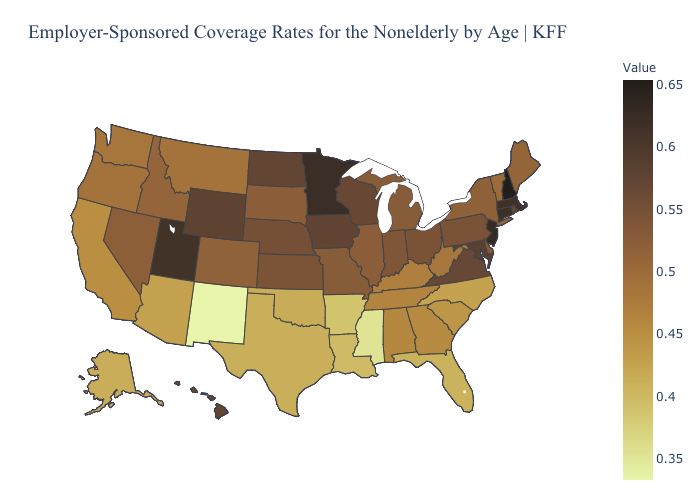Among the states that border Arkansas , which have the lowest value?
Concise answer only. Mississippi. Which states have the highest value in the USA?
Keep it brief. New Hampshire. Does Mississippi have the lowest value in the South?
Answer briefly. Yes. Does West Virginia have the highest value in the USA?
Be succinct. No. Does New Hampshire have the highest value in the USA?
Quick response, please. Yes. Which states have the highest value in the USA?
Give a very brief answer. New Hampshire. 